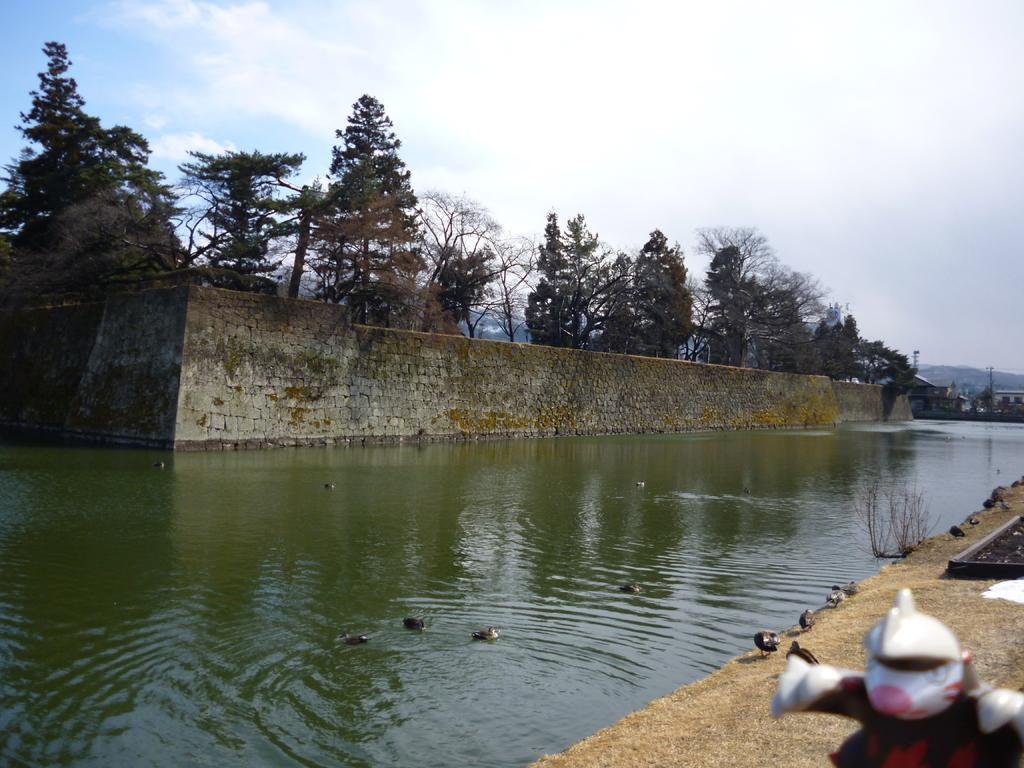What type of animals can be seen in the image? Birds can be seen in the image. What is the primary element in which the birds are situated? The birds are situated in water. What can be seen in the background of the image? There are trees and houses in the background of the image. How many brothers are visible in the image? There are no brothers present in the image. What type of cup can be seen in the hands of the man in the image? There is no man or cup present in the image. 